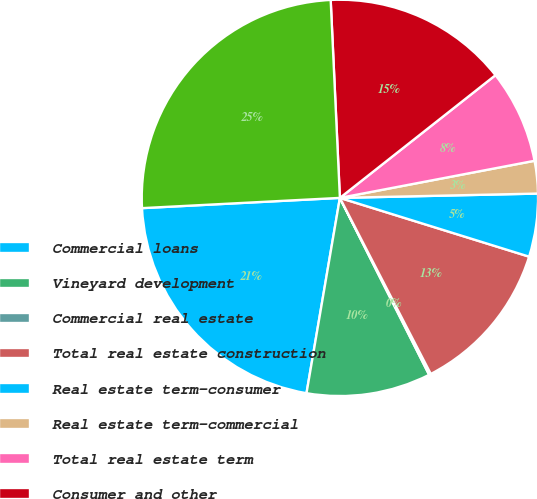<chart> <loc_0><loc_0><loc_500><loc_500><pie_chart><fcel>Commercial loans<fcel>Vineyard development<fcel>Commercial real estate<fcel>Total real estate construction<fcel>Real estate term-consumer<fcel>Real estate term-commercial<fcel>Total real estate term<fcel>Consumer and other<fcel>Total loans net of unearned<nl><fcel>21.48%<fcel>10.13%<fcel>0.15%<fcel>12.62%<fcel>5.14%<fcel>2.65%<fcel>7.63%<fcel>15.11%<fcel>25.08%<nl></chart> 